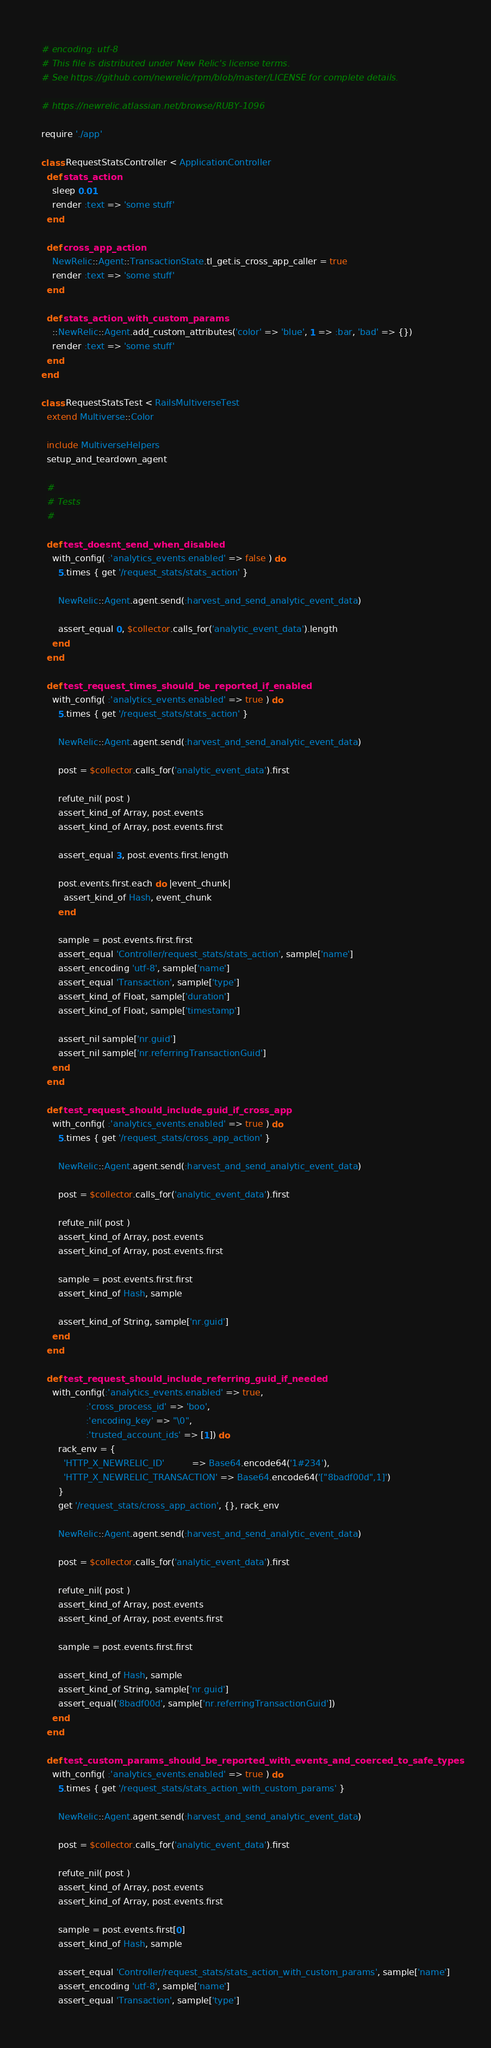Convert code to text. <code><loc_0><loc_0><loc_500><loc_500><_Ruby_># encoding: utf-8
# This file is distributed under New Relic's license terms.
# See https://github.com/newrelic/rpm/blob/master/LICENSE for complete details.

# https://newrelic.atlassian.net/browse/RUBY-1096

require './app'

class RequestStatsController < ApplicationController
  def stats_action
    sleep 0.01
    render :text => 'some stuff'
  end

  def cross_app_action
    NewRelic::Agent::TransactionState.tl_get.is_cross_app_caller = true
    render :text => 'some stuff'
  end

  def stats_action_with_custom_params
    ::NewRelic::Agent.add_custom_attributes('color' => 'blue', 1 => :bar, 'bad' => {})
    render :text => 'some stuff'
  end
end

class RequestStatsTest < RailsMultiverseTest
  extend Multiverse::Color

  include MultiverseHelpers
  setup_and_teardown_agent

  #
  # Tests
  #

  def test_doesnt_send_when_disabled
    with_config( :'analytics_events.enabled' => false ) do
      5.times { get '/request_stats/stats_action' }

      NewRelic::Agent.agent.send(:harvest_and_send_analytic_event_data)

      assert_equal 0, $collector.calls_for('analytic_event_data').length
    end
  end

  def test_request_times_should_be_reported_if_enabled
    with_config( :'analytics_events.enabled' => true ) do
      5.times { get '/request_stats/stats_action' }

      NewRelic::Agent.agent.send(:harvest_and_send_analytic_event_data)

      post = $collector.calls_for('analytic_event_data').first

      refute_nil( post )
      assert_kind_of Array, post.events
      assert_kind_of Array, post.events.first

      assert_equal 3, post.events.first.length

      post.events.first.each do |event_chunk|
        assert_kind_of Hash, event_chunk
      end

      sample = post.events.first.first
      assert_equal 'Controller/request_stats/stats_action', sample['name']
      assert_encoding 'utf-8', sample['name']
      assert_equal 'Transaction', sample['type']
      assert_kind_of Float, sample['duration']
      assert_kind_of Float, sample['timestamp']

      assert_nil sample['nr.guid']
      assert_nil sample['nr.referringTransactionGuid']
    end
  end

  def test_request_should_include_guid_if_cross_app
    with_config( :'analytics_events.enabled' => true ) do
      5.times { get '/request_stats/cross_app_action' }

      NewRelic::Agent.agent.send(:harvest_and_send_analytic_event_data)

      post = $collector.calls_for('analytic_event_data').first

      refute_nil( post )
      assert_kind_of Array, post.events
      assert_kind_of Array, post.events.first

      sample = post.events.first.first
      assert_kind_of Hash, sample

      assert_kind_of String, sample['nr.guid']
    end
  end

  def test_request_should_include_referring_guid_if_needed
    with_config(:'analytics_events.enabled' => true,
                :'cross_process_id' => 'boo',
                :'encoding_key' => "\0",
                :'trusted_account_ids' => [1]) do
      rack_env = {
        'HTTP_X_NEWRELIC_ID'          => Base64.encode64('1#234'),
        'HTTP_X_NEWRELIC_TRANSACTION' => Base64.encode64('["8badf00d",1]')
      }
      get '/request_stats/cross_app_action', {}, rack_env

      NewRelic::Agent.agent.send(:harvest_and_send_analytic_event_data)

      post = $collector.calls_for('analytic_event_data').first

      refute_nil( post )
      assert_kind_of Array, post.events
      assert_kind_of Array, post.events.first

      sample = post.events.first.first

      assert_kind_of Hash, sample
      assert_kind_of String, sample['nr.guid']
      assert_equal('8badf00d', sample['nr.referringTransactionGuid'])
    end
  end

  def test_custom_params_should_be_reported_with_events_and_coerced_to_safe_types
    with_config( :'analytics_events.enabled' => true ) do
      5.times { get '/request_stats/stats_action_with_custom_params' }

      NewRelic::Agent.agent.send(:harvest_and_send_analytic_event_data)

      post = $collector.calls_for('analytic_event_data').first

      refute_nil( post )
      assert_kind_of Array, post.events
      assert_kind_of Array, post.events.first

      sample = post.events.first[0]
      assert_kind_of Hash, sample

      assert_equal 'Controller/request_stats/stats_action_with_custom_params', sample['name']
      assert_encoding 'utf-8', sample['name']
      assert_equal 'Transaction', sample['type']
</code> 